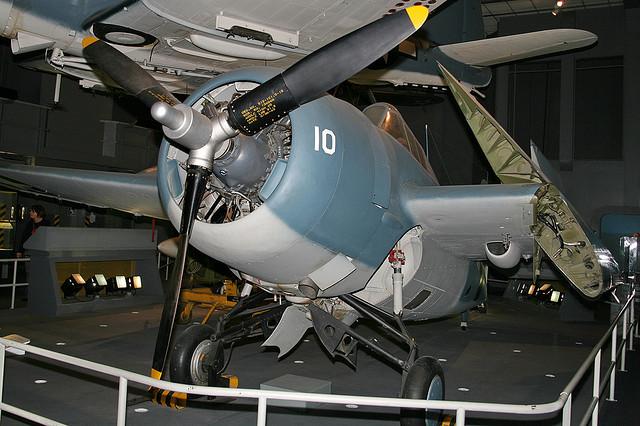What number is on the plane?
Keep it brief. 10. What kind of plane is this?
Answer briefly. Fighter. Is this plane in use?
Quick response, please. No. 